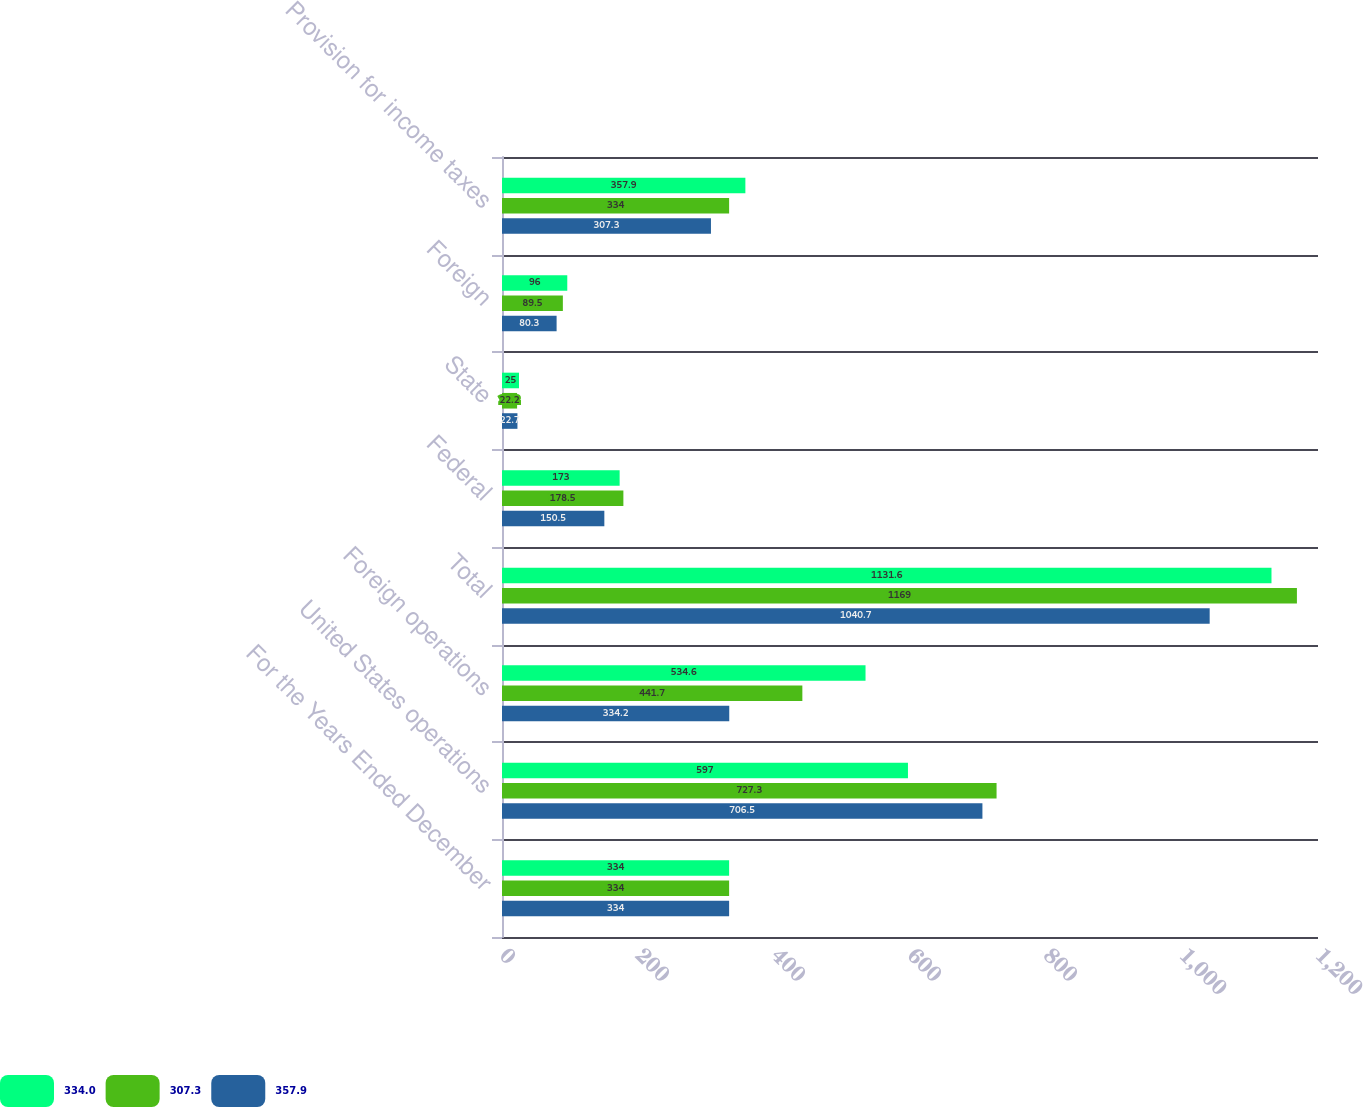<chart> <loc_0><loc_0><loc_500><loc_500><stacked_bar_chart><ecel><fcel>For the Years Ended December<fcel>United States operations<fcel>Foreign operations<fcel>Total<fcel>Federal<fcel>State<fcel>Foreign<fcel>Provision for income taxes<nl><fcel>334<fcel>334<fcel>597<fcel>534.6<fcel>1131.6<fcel>173<fcel>25<fcel>96<fcel>357.9<nl><fcel>307.3<fcel>334<fcel>727.3<fcel>441.7<fcel>1169<fcel>178.5<fcel>22.2<fcel>89.5<fcel>334<nl><fcel>357.9<fcel>334<fcel>706.5<fcel>334.2<fcel>1040.7<fcel>150.5<fcel>22.7<fcel>80.3<fcel>307.3<nl></chart> 